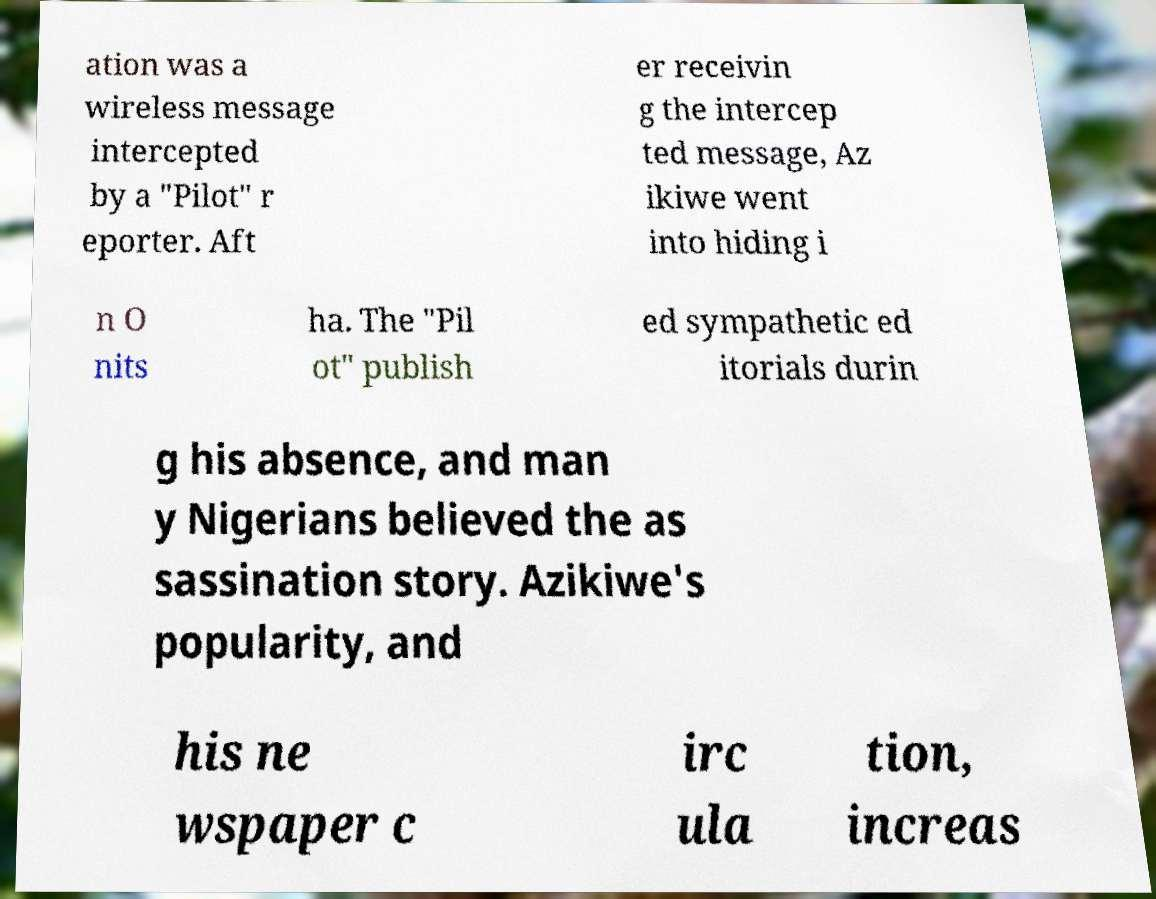I need the written content from this picture converted into text. Can you do that? ation was a wireless message intercepted by a "Pilot" r eporter. Aft er receivin g the intercep ted message, Az ikiwe went into hiding i n O nits ha. The "Pil ot" publish ed sympathetic ed itorials durin g his absence, and man y Nigerians believed the as sassination story. Azikiwe's popularity, and his ne wspaper c irc ula tion, increas 